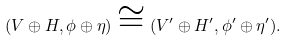Convert formula to latex. <formula><loc_0><loc_0><loc_500><loc_500>( V \oplus H , \phi \oplus \eta ) \cong ( V ^ { \prime } \oplus H ^ { \prime } , \phi ^ { \prime } \oplus \eta ^ { \prime } ) .</formula> 